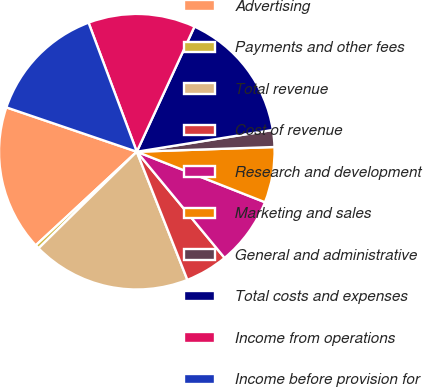<chart> <loc_0><loc_0><loc_500><loc_500><pie_chart><fcel>Advertising<fcel>Payments and other fees<fcel>Total revenue<fcel>Cost of revenue<fcel>Research and development<fcel>Marketing and sales<fcel>General and administrative<fcel>Total costs and expenses<fcel>Income from operations<fcel>Income before provision for<nl><fcel>17.11%<fcel>0.47%<fcel>18.62%<fcel>5.01%<fcel>8.03%<fcel>6.52%<fcel>1.98%<fcel>15.6%<fcel>12.57%<fcel>14.09%<nl></chart> 